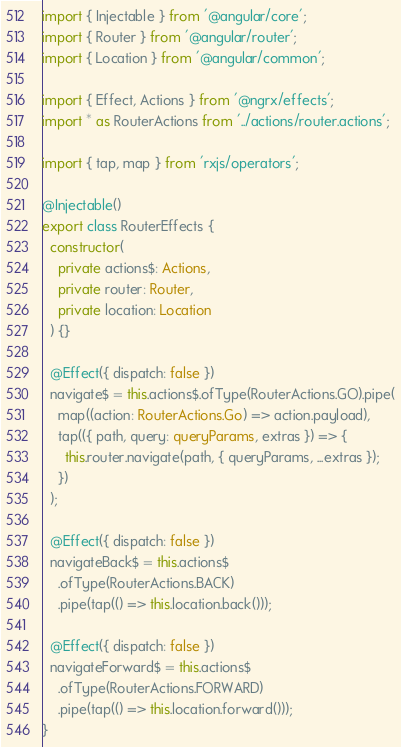Convert code to text. <code><loc_0><loc_0><loc_500><loc_500><_TypeScript_>import { Injectable } from '@angular/core';
import { Router } from '@angular/router';
import { Location } from '@angular/common';

import { Effect, Actions } from '@ngrx/effects';
import * as RouterActions from '../actions/router.actions';

import { tap, map } from 'rxjs/operators';

@Injectable()
export class RouterEffects {
  constructor(
    private actions$: Actions,
    private router: Router,
    private location: Location
  ) {}

  @Effect({ dispatch: false })
  navigate$ = this.actions$.ofType(RouterActions.GO).pipe(
    map((action: RouterActions.Go) => action.payload),
    tap(({ path, query: queryParams, extras }) => {
      this.router.navigate(path, { queryParams, ...extras });
    })
  );

  @Effect({ dispatch: false })
  navigateBack$ = this.actions$
    .ofType(RouterActions.BACK)
    .pipe(tap(() => this.location.back()));

  @Effect({ dispatch: false })
  navigateForward$ = this.actions$
    .ofType(RouterActions.FORWARD)
    .pipe(tap(() => this.location.forward()));
}
</code> 